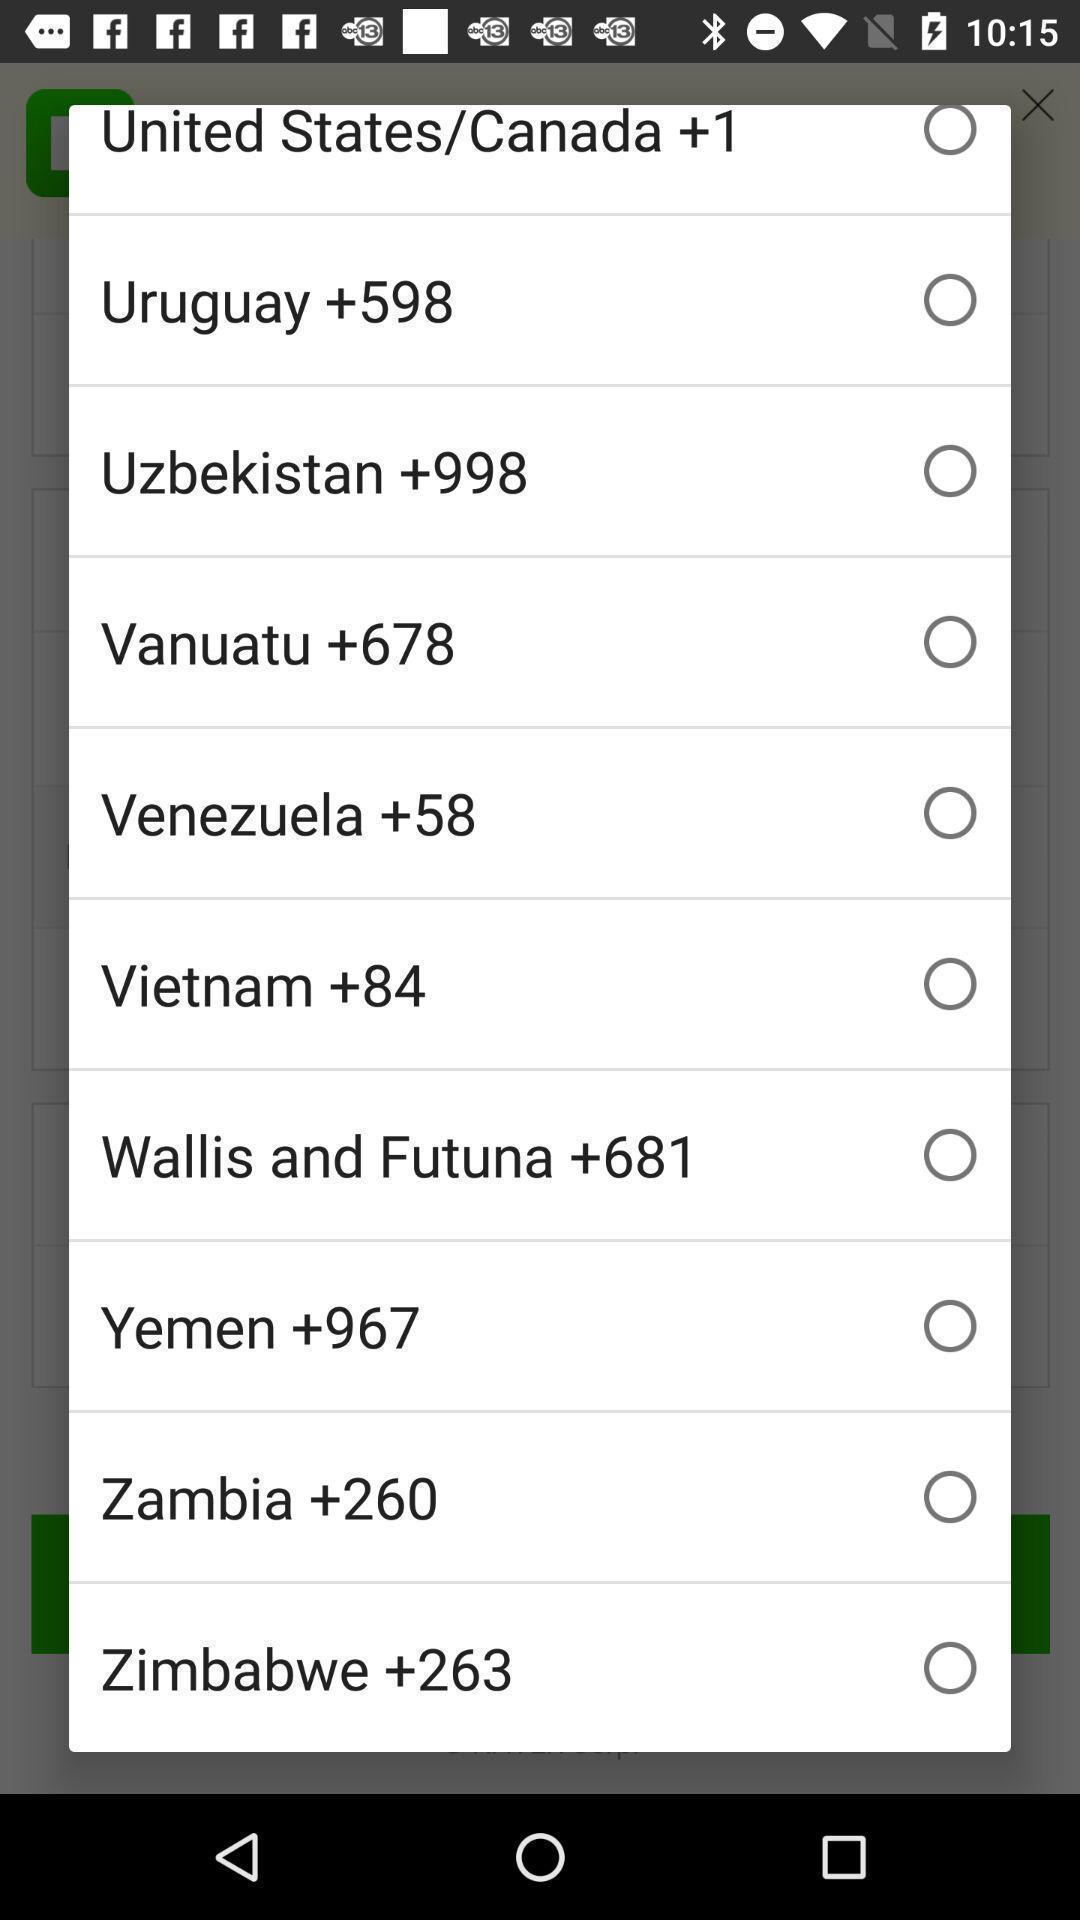Explain what's happening in this screen capture. Pop-up display list of various cities. 